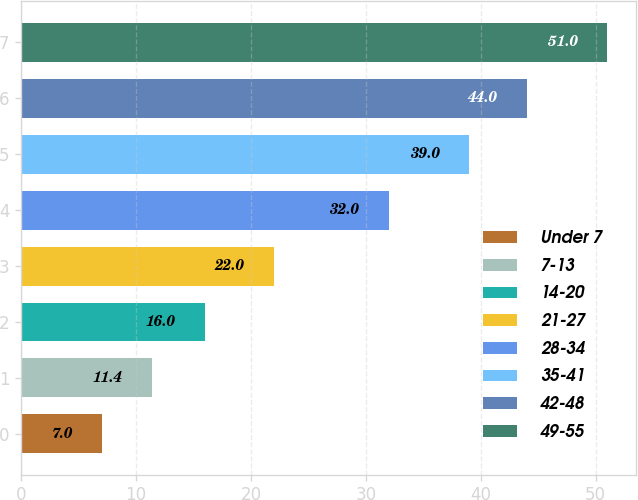Convert chart. <chart><loc_0><loc_0><loc_500><loc_500><bar_chart><fcel>Under 7<fcel>7-13<fcel>14-20<fcel>21-27<fcel>28-34<fcel>35-41<fcel>42-48<fcel>49-55<nl><fcel>7<fcel>11.4<fcel>16<fcel>22<fcel>32<fcel>39<fcel>44<fcel>51<nl></chart> 